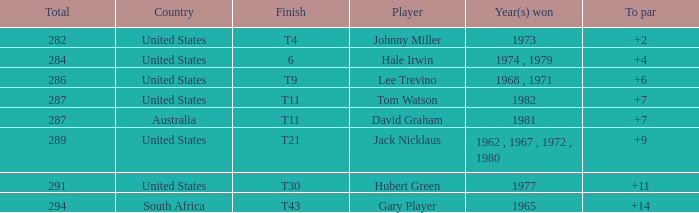WHAT IS THE TO PAR WITH A FINISH OF T11, FOR DAVID GRAHAM? 7.0. 